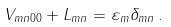<formula> <loc_0><loc_0><loc_500><loc_500>V _ { m n 0 0 } + L _ { m n } = \varepsilon _ { m } \delta _ { m n } \, .</formula> 